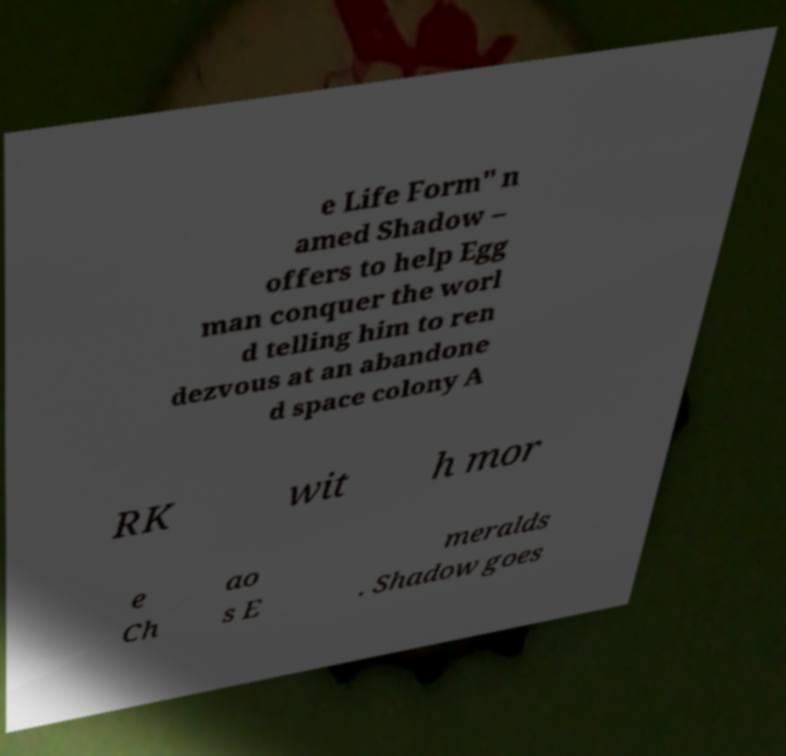Could you extract and type out the text from this image? e Life Form" n amed Shadow – offers to help Egg man conquer the worl d telling him to ren dezvous at an abandone d space colony A RK wit h mor e Ch ao s E meralds . Shadow goes 